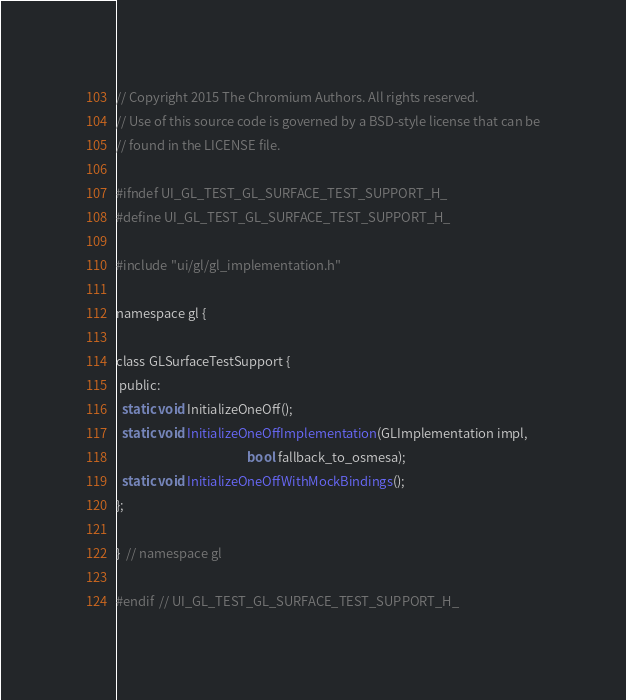<code> <loc_0><loc_0><loc_500><loc_500><_C_>// Copyright 2015 The Chromium Authors. All rights reserved.
// Use of this source code is governed by a BSD-style license that can be
// found in the LICENSE file.

#ifndef UI_GL_TEST_GL_SURFACE_TEST_SUPPORT_H_
#define UI_GL_TEST_GL_SURFACE_TEST_SUPPORT_H_

#include "ui/gl/gl_implementation.h"

namespace gl {

class GLSurfaceTestSupport {
 public:
  static void InitializeOneOff();
  static void InitializeOneOffImplementation(GLImplementation impl,
                                             bool fallback_to_osmesa);
  static void InitializeOneOffWithMockBindings();
};

}  // namespace gl

#endif  // UI_GL_TEST_GL_SURFACE_TEST_SUPPORT_H_
</code> 